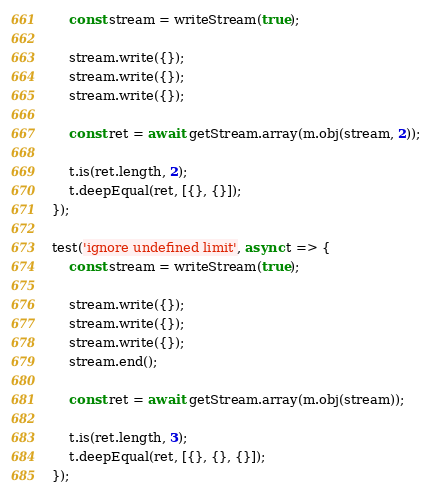Convert code to text. <code><loc_0><loc_0><loc_500><loc_500><_JavaScript_>	const stream = writeStream(true);

	stream.write({});
	stream.write({});
	stream.write({});

	const ret = await getStream.array(m.obj(stream, 2));

	t.is(ret.length, 2);
	t.deepEqual(ret, [{}, {}]);
});

test('ignore undefined limit', async t => {
	const stream = writeStream(true);

	stream.write({});
	stream.write({});
	stream.write({});
	stream.end();

	const ret = await getStream.array(m.obj(stream));

	t.is(ret.length, 3);
	t.deepEqual(ret, [{}, {}, {}]);
});
</code> 